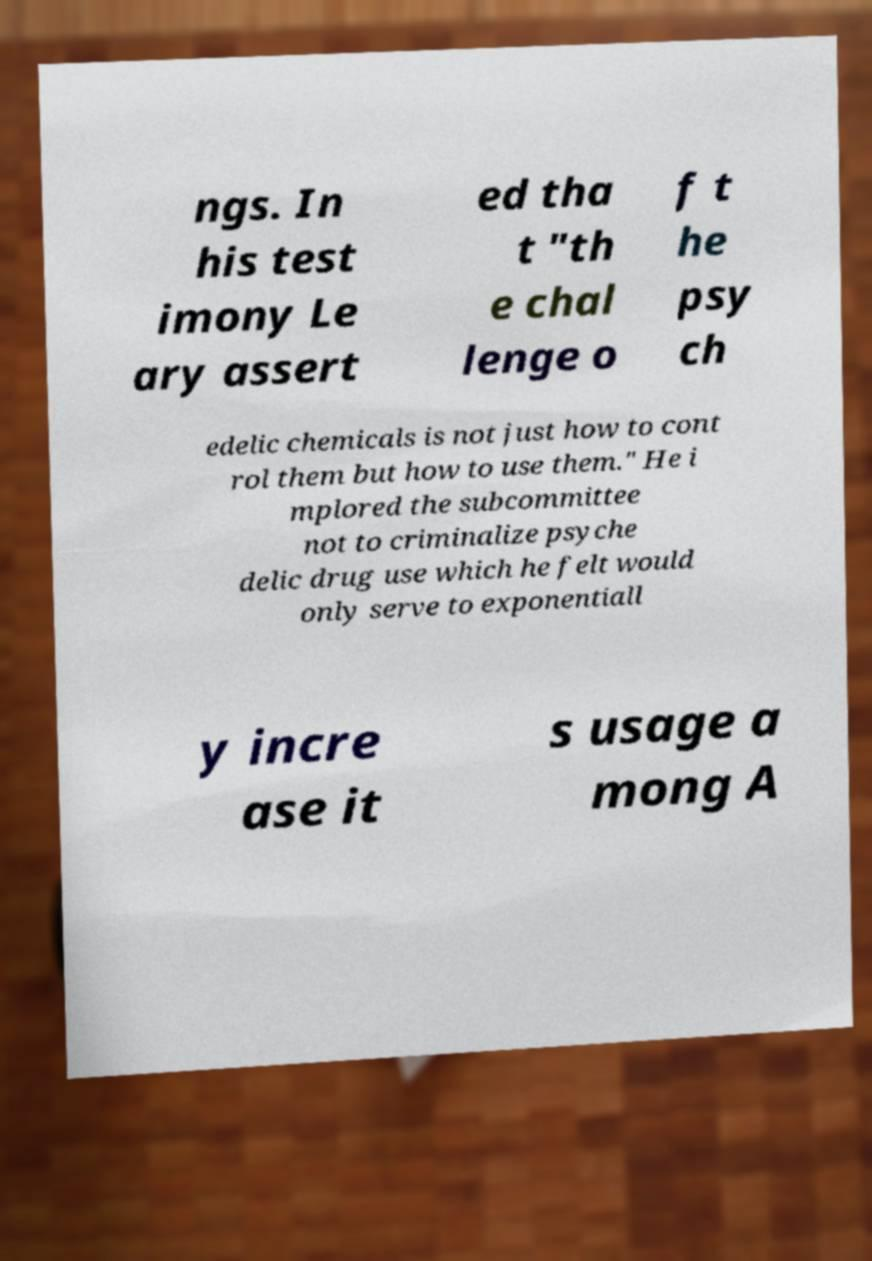What messages or text are displayed in this image? I need them in a readable, typed format. ngs. In his test imony Le ary assert ed tha t "th e chal lenge o f t he psy ch edelic chemicals is not just how to cont rol them but how to use them." He i mplored the subcommittee not to criminalize psyche delic drug use which he felt would only serve to exponentiall y incre ase it s usage a mong A 